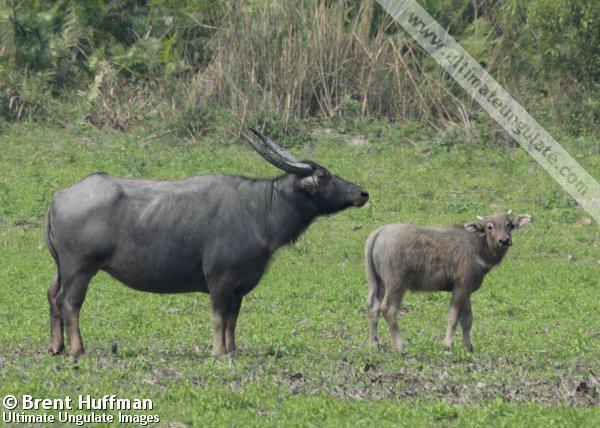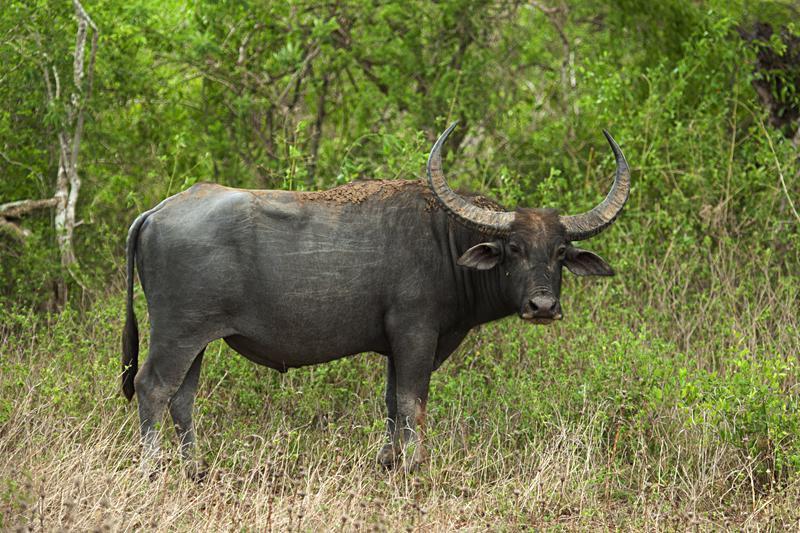The first image is the image on the left, the second image is the image on the right. Analyze the images presented: Is the assertion "The animals in the image on the left are near an area of water." valid? Answer yes or no. No. The first image is the image on the left, the second image is the image on the right. Assess this claim about the two images: "An image shows exactly two water buffalo standing in profile.". Correct or not? Answer yes or no. Yes. 